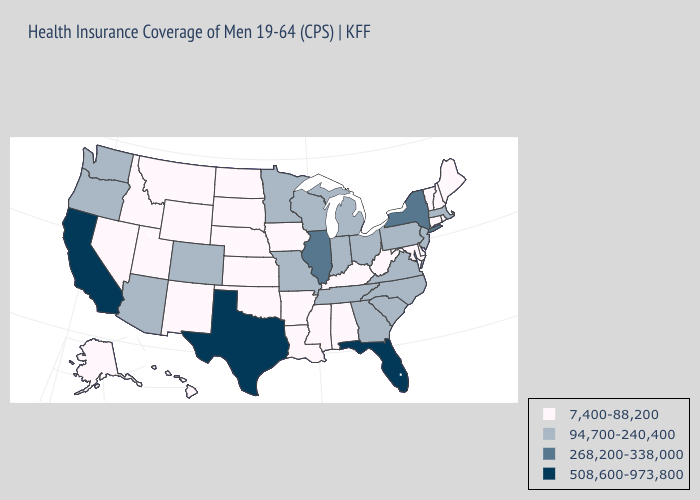What is the value of Vermont?
Short answer required. 7,400-88,200. Does South Carolina have a higher value than North Carolina?
Keep it brief. No. What is the lowest value in the Northeast?
Answer briefly. 7,400-88,200. Does Illinois have the highest value in the MidWest?
Answer briefly. Yes. What is the highest value in states that border Texas?
Concise answer only. 7,400-88,200. Does Georgia have the lowest value in the USA?
Concise answer only. No. Name the states that have a value in the range 268,200-338,000?
Be succinct. Illinois, New York. Which states have the highest value in the USA?
Be succinct. California, Florida, Texas. Among the states that border Mississippi , does Arkansas have the lowest value?
Concise answer only. Yes. Among the states that border Virginia , does Tennessee have the lowest value?
Quick response, please. No. Which states have the highest value in the USA?
Answer briefly. California, Florida, Texas. Which states hav the highest value in the South?
Keep it brief. Florida, Texas. Does Missouri have a lower value than Arizona?
Concise answer only. No. What is the value of Virginia?
Concise answer only. 94,700-240,400. What is the value of Louisiana?
Be succinct. 7,400-88,200. 